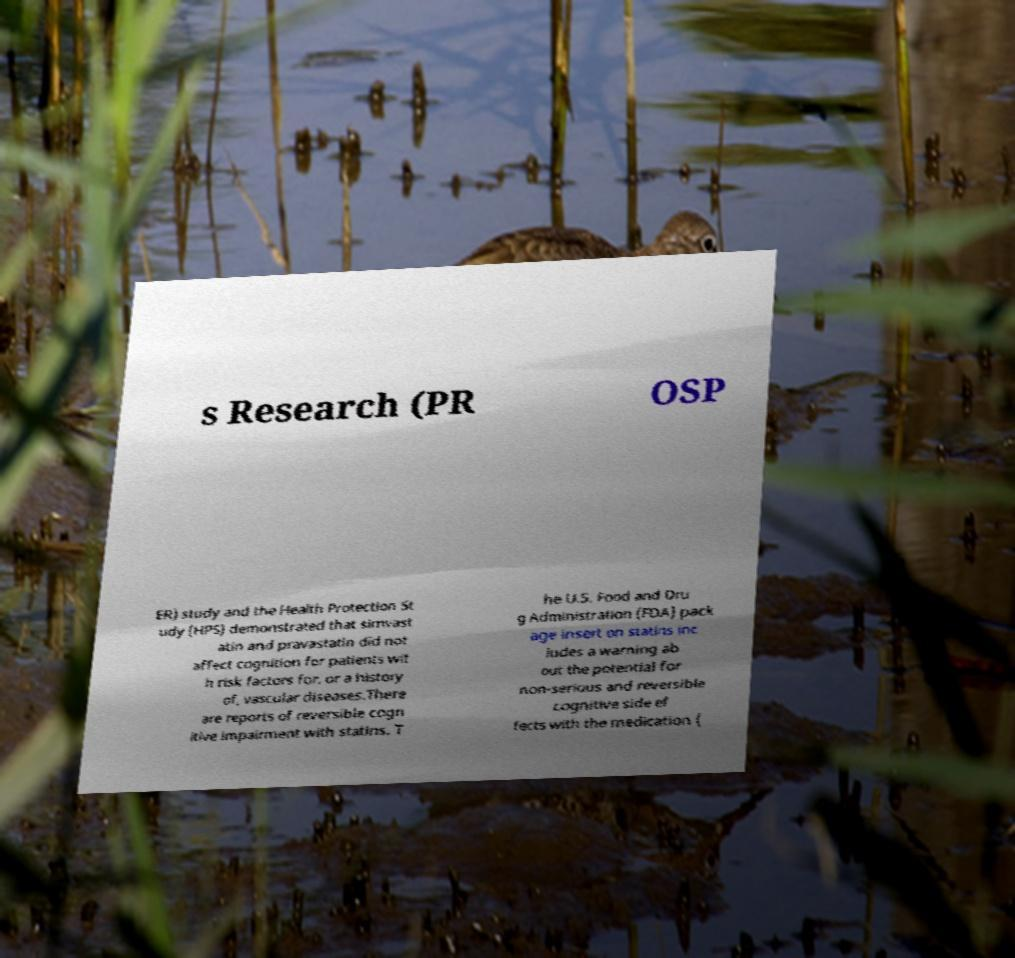Could you extract and type out the text from this image? s Research (PR OSP ER) study and the Health Protection St udy (HPS) demonstrated that simvast atin and pravastatin did not affect cognition for patients wit h risk factors for, or a history of, vascular diseases.There are reports of reversible cogn itive impairment with statins. T he U.S. Food and Dru g Administration (FDA) pack age insert on statins inc ludes a warning ab out the potential for non-serious and reversible cognitive side ef fects with the medication ( 